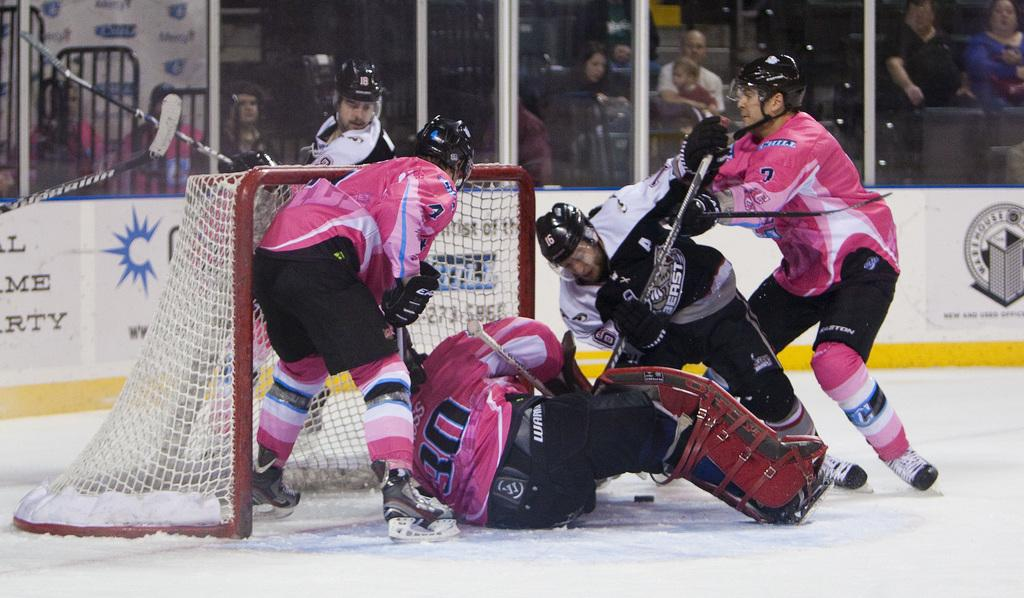<image>
Share a concise interpretation of the image provided. Several hockey players are on top of the goalie with the number 30 on their back. 